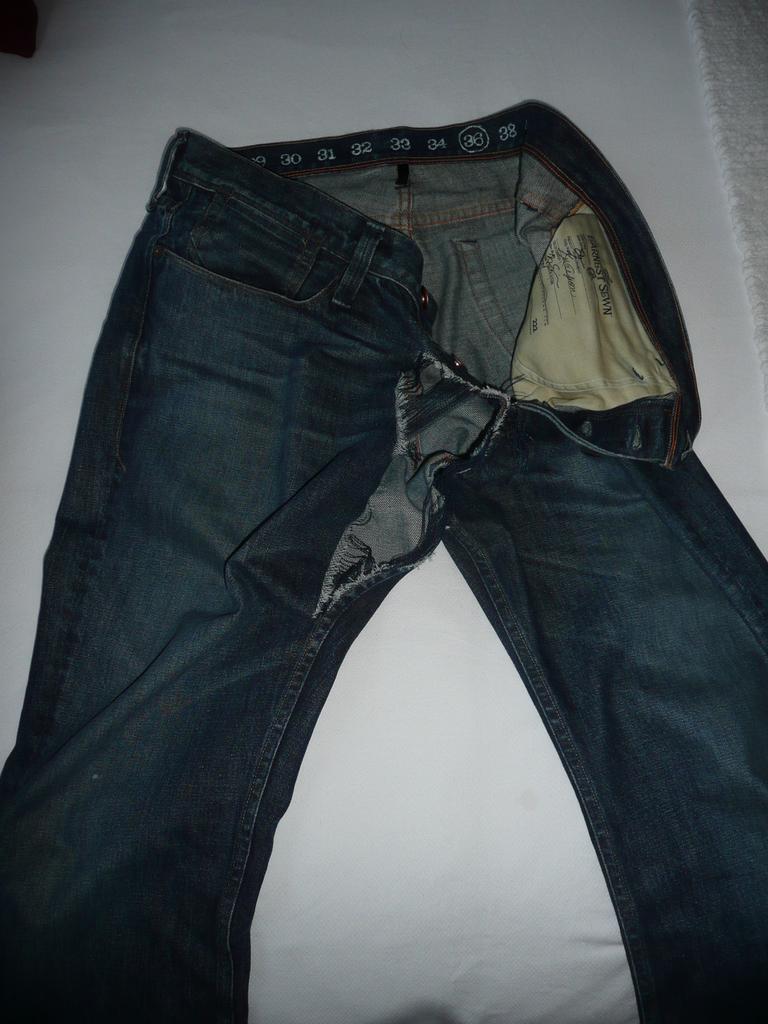Please provide a concise description of this image. In the background there is a white surface. In the middle of the image there is a jeans on the white surface. The jean is torn. 